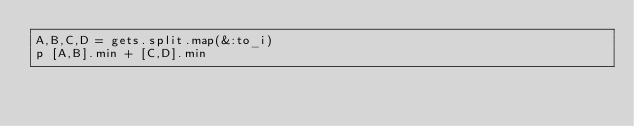Convert code to text. <code><loc_0><loc_0><loc_500><loc_500><_Ruby_>A,B,C,D = gets.split.map(&:to_i)
p [A,B].min + [C,D].min
</code> 